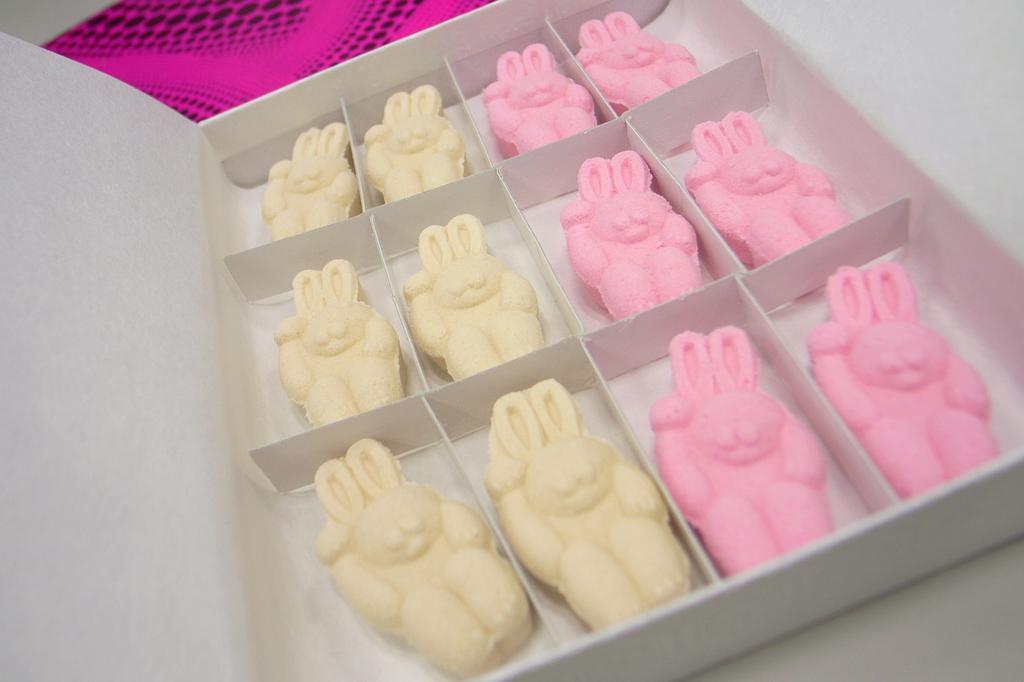Could you give a brief overview of what you see in this image? In this image there are food items in the box. Beside the box there is some object on the table. 